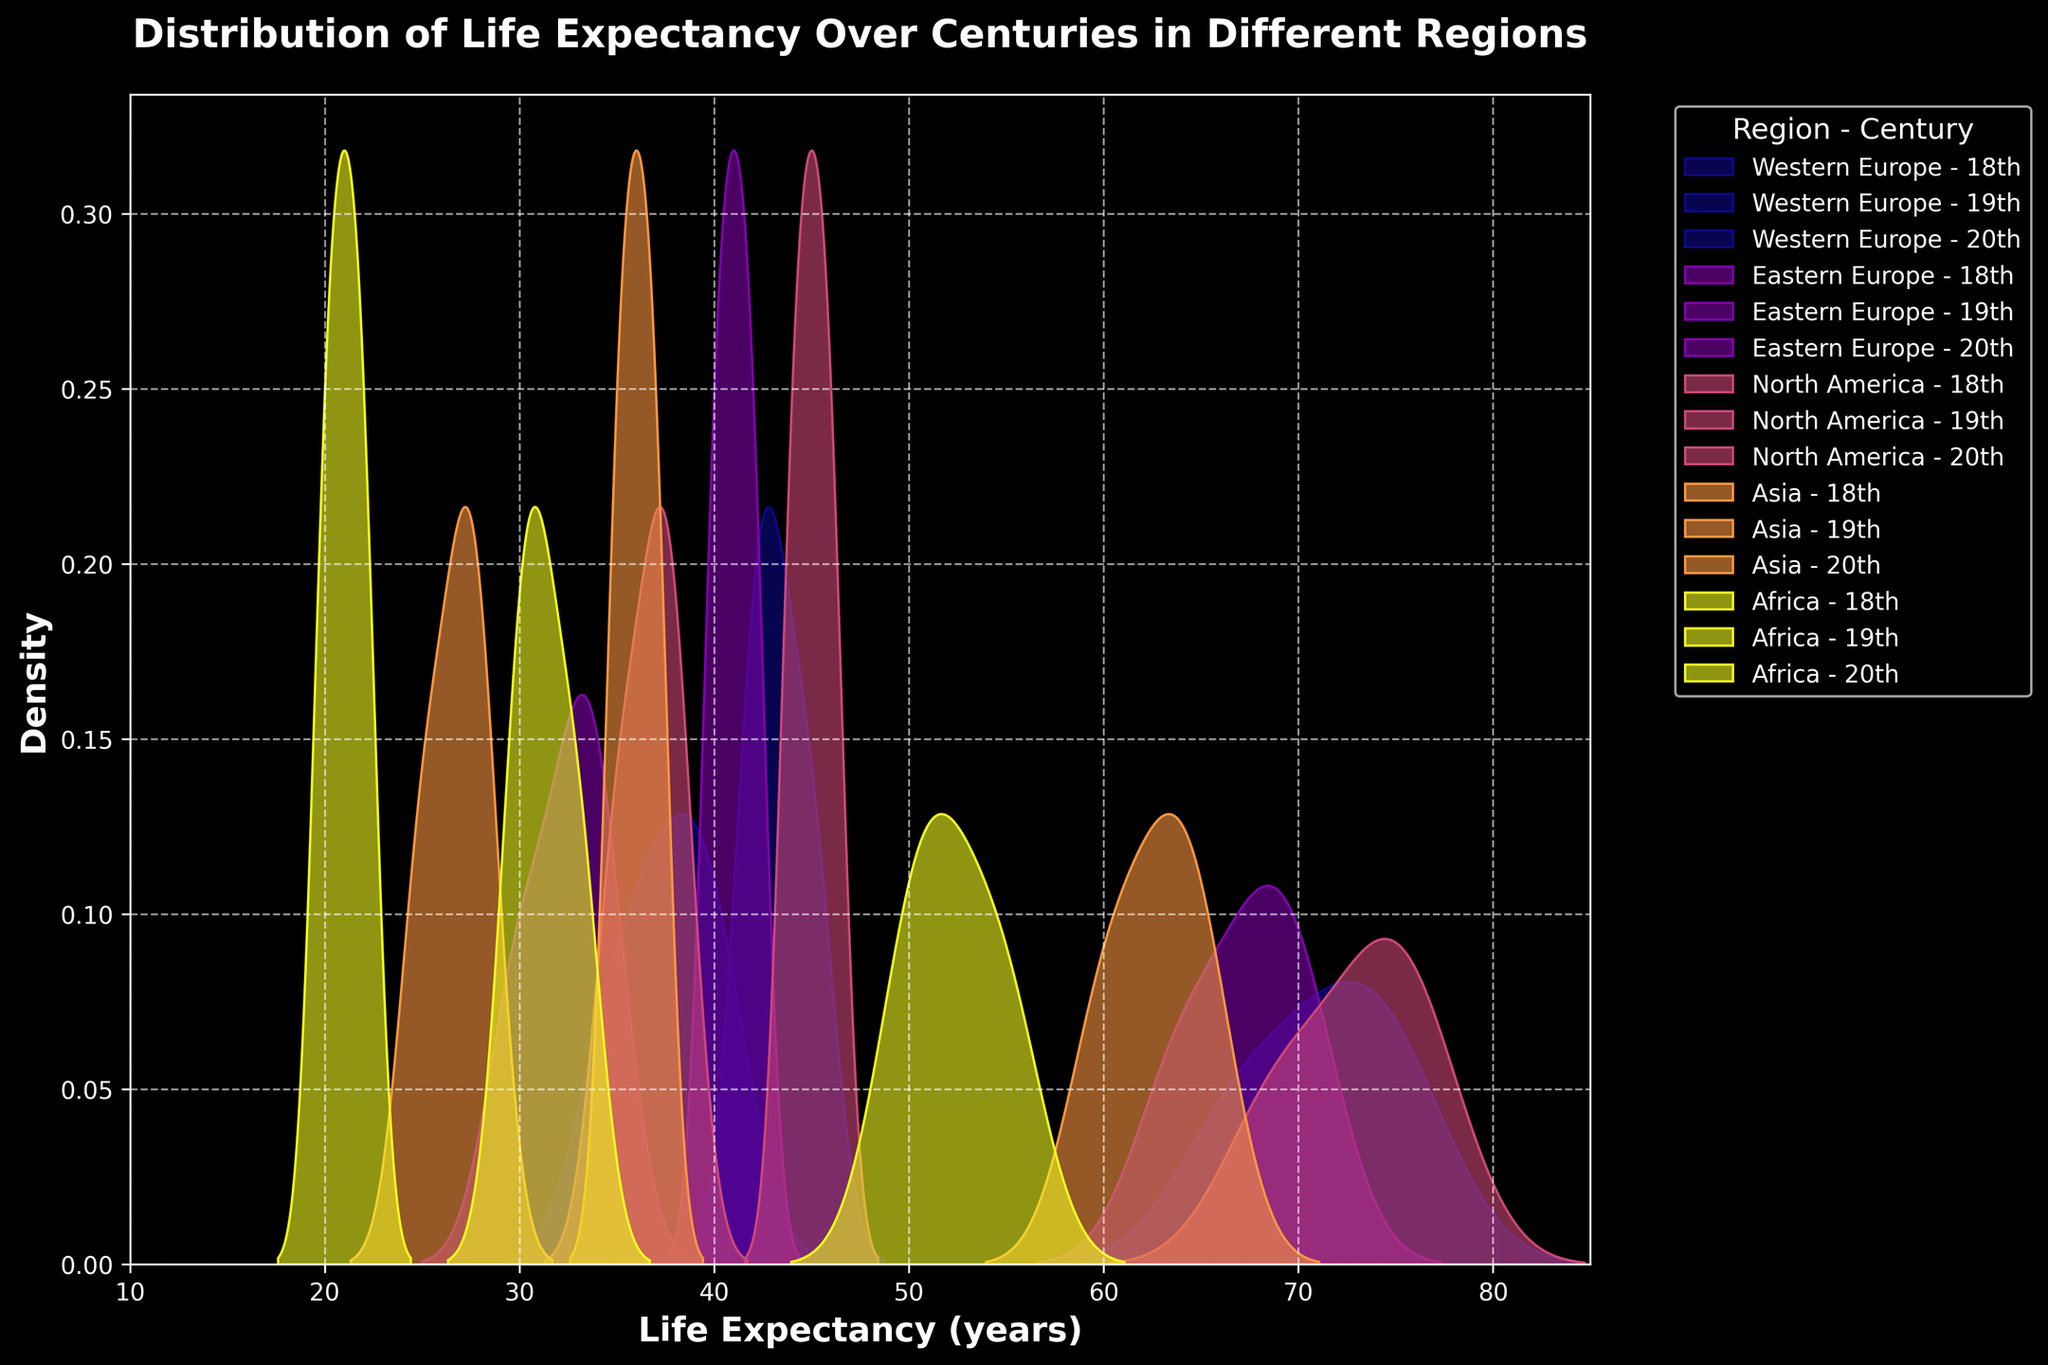What is the title of the plot? The title is usually displayed at the top of the figure. In this case, the title is "Distribution of Life Expectancy Over Centuries in Different Regions", which indicates what the data and the visualizations are about.
Answer: Distribution of Life Expectancy Over Centuries in Different Regions What does the x-axis represent? The x-axis label provides information about the data represented on the horizontal axis. In this case, the label "Life Expectancy (years)" denotes that the x-axis represents the life expectancy in years.
Answer: Life Expectancy (years) What are the century intervals considered in the plot? By looking at the labels used in the plot legend, we can see different centuries being compared. The centuries represented are the 18th, 19th, and 20th centuries.
Answer: 18th, 19th, 20th centuries Which region has the highest life expectancy distribution in the 20th century? Observing the kde plots, we see that North America in the 20th century displays the highest life expectancy distribution, indicating the distribution peaks at a higher life expectancy.
Answer: North America How does life expectancy in Western Europe compare across the three centuries? Comparing the kde plots for Western Europe, it is clear that there is an increase in life expectancy from the 18th to the 20th century. The peak of the distributions shifts to the right over time.
Answer: It increases What is the overall color theme of the plot? The plot uses a dark background theme with distinct colors assigned to different regions. This color scheme helps distinguish between different data groups.
Answer: Dark background Which region had the lowest life expectancy in the 18th century? By observing the kde plots, it becomes apparent that Africa in the 18th century has the lowest life expectancy, indicated by the leftmost distribution peak.
Answer: Africa What trend can be observed in life expectancy in Asia across the centuries? Looking at the distribution peaks for Asia, there is a clear upward trend in life expectancy from the 18th to the 20th century, with each subsequent peak occurring further to the right.
Answer: It increases Do any regions have overlapping life expectancy distributions in the 19th century? Comparing the kde plots for the 19th century, Eastern Europe and North America have overlapping distributions, suggesting similar life expectancy ranges during this period.
Answer: Eastern Europe and North America Which century shows the most significant increase in life expectancy for all regions? By viewing the spread of distributions across all regions, the most substantial increase is seen from the 19th to the 20th century, where a noticeable shift to higher life expectancies can be observed across all regions.
Answer: 19th to 20th century 